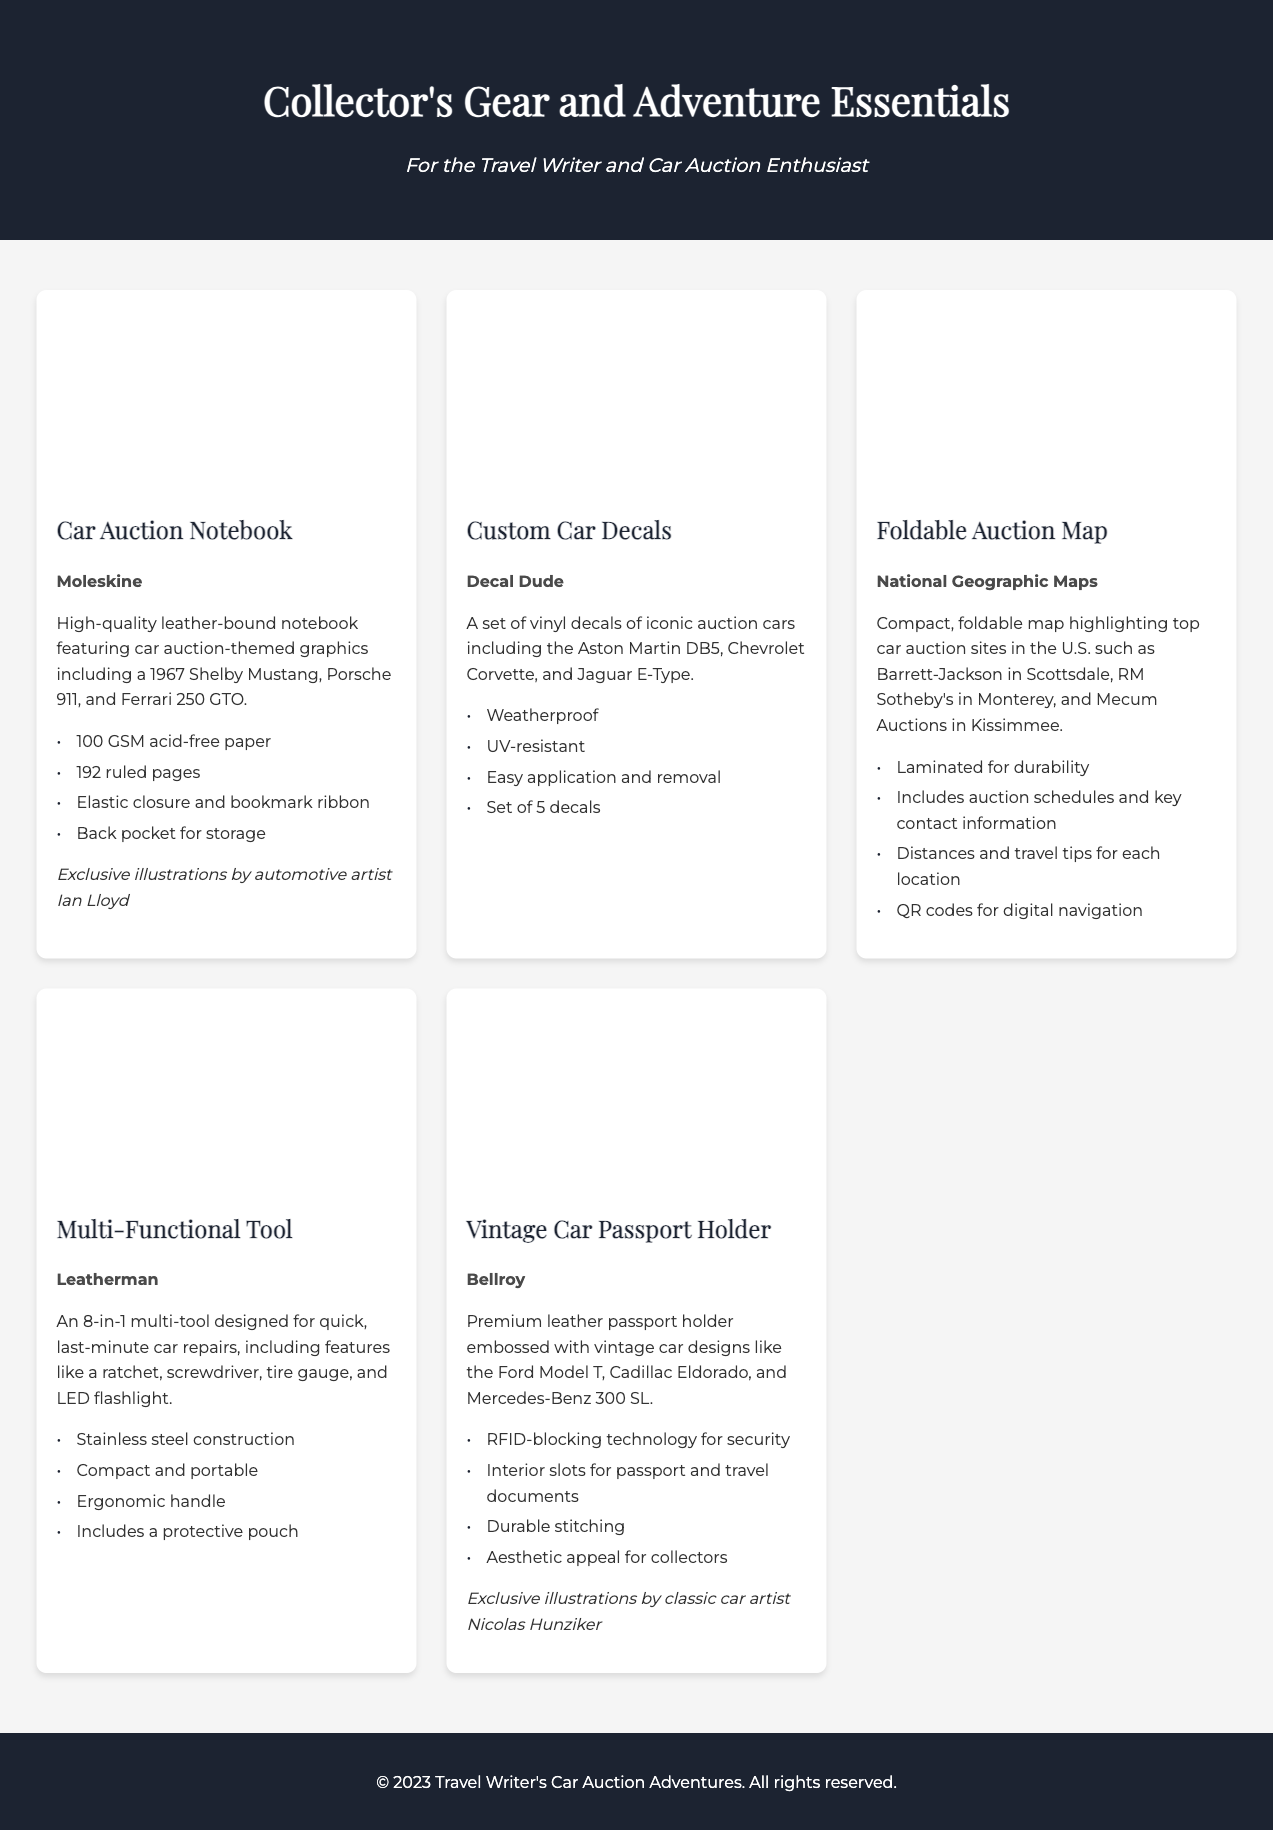what is the brand of the Car Auction Notebook? The brand is explicitly mentioned in the description of the product card for the Car Auction Notebook.
Answer: Moleskine how many pages does the Car Auction Notebook have? The product description states that the Car Auction Notebook has 192 ruled pages.
Answer: 192 what type of materials are the Custom Car Decals made from? The product description provides information about the materials used for creating the Custom Car Decals.
Answer: Vinyl which company produces the Vintage Car Passport Holder? The brand of the Vintage Car Passport Holder is specified in its product card.
Answer: Bellroy how many auction locations are highlighted on the Foldable Auction Map? The Foldable Auction Map mentions specific top car auction sites, indicating multiple locations.
Answer: Several (specific sites can be noted) what is one feature of the multi-functional tool? The multi-functional tool's description lists various features, one of which is a ratchet.
Answer: Ratchet what is unique about the Car Auction Notebook's illustrations? The product description mentions the source of the illustrations in the Car Auction Notebook.
Answer: Exclusive illustrations by automotive artist Ian Lloyd how many decals come in the Custom Car Decals set? The description of the Custom Car Decals specifies the number of decals in the set.
Answer: Set of 5 decals 